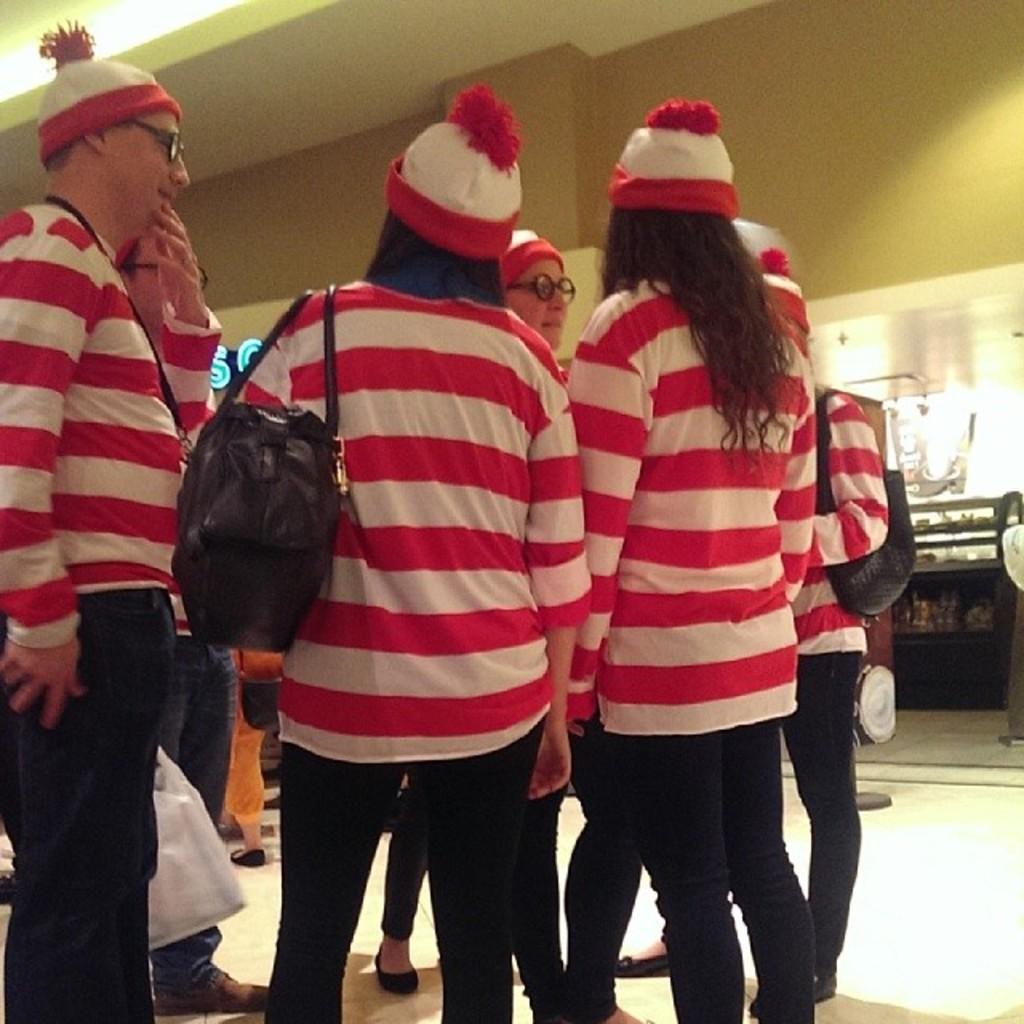Can you describe this image briefly? In the foreground I can see a group of people are standing on the floor and are wearing bags. In the background I can see a wall and a table. This image is taken may be in a hall. 